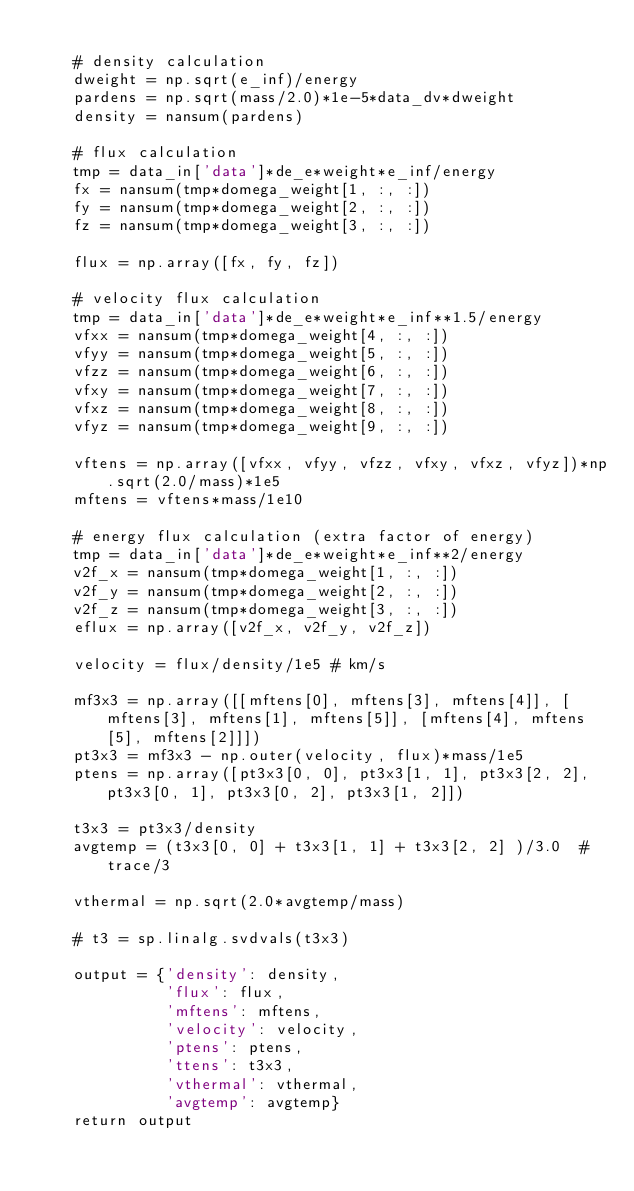<code> <loc_0><loc_0><loc_500><loc_500><_Python_>
    # density calculation
    dweight = np.sqrt(e_inf)/energy
    pardens = np.sqrt(mass/2.0)*1e-5*data_dv*dweight
    density = nansum(pardens)

    # flux calculation
    tmp = data_in['data']*de_e*weight*e_inf/energy
    fx = nansum(tmp*domega_weight[1, :, :])
    fy = nansum(tmp*domega_weight[2, :, :])
    fz = nansum(tmp*domega_weight[3, :, :])

    flux = np.array([fx, fy, fz])

    # velocity flux calculation
    tmp = data_in['data']*de_e*weight*e_inf**1.5/energy
    vfxx = nansum(tmp*domega_weight[4, :, :])
    vfyy = nansum(tmp*domega_weight[5, :, :])
    vfzz = nansum(tmp*domega_weight[6, :, :])
    vfxy = nansum(tmp*domega_weight[7, :, :])
    vfxz = nansum(tmp*domega_weight[8, :, :])
    vfyz = nansum(tmp*domega_weight[9, :, :])

    vftens = np.array([vfxx, vfyy, vfzz, vfxy, vfxz, vfyz])*np.sqrt(2.0/mass)*1e5
    mftens = vftens*mass/1e10

    # energy flux calculation (extra factor of energy)
    tmp = data_in['data']*de_e*weight*e_inf**2/energy
    v2f_x = nansum(tmp*domega_weight[1, :, :])
    v2f_y = nansum(tmp*domega_weight[2, :, :])
    v2f_z = nansum(tmp*domega_weight[3, :, :])
    eflux = np.array([v2f_x, v2f_y, v2f_z])

    velocity = flux/density/1e5 # km/s

    mf3x3 = np.array([[mftens[0], mftens[3], mftens[4]], [mftens[3], mftens[1], mftens[5]], [mftens[4], mftens[5], mftens[2]]])
    pt3x3 = mf3x3 - np.outer(velocity, flux)*mass/1e5
    ptens = np.array([pt3x3[0, 0], pt3x3[1, 1], pt3x3[2, 2], pt3x3[0, 1], pt3x3[0, 2], pt3x3[1, 2]])

    t3x3 = pt3x3/density
    avgtemp = (t3x3[0, 0] + t3x3[1, 1] + t3x3[2, 2] )/3.0  # trace/3

    vthermal = np.sqrt(2.0*avgtemp/mass)

    # t3 = sp.linalg.svdvals(t3x3)
    
    output = {'density': density, 
              'flux': flux, 
              'mftens': mftens, 
              'velocity': velocity, 
              'ptens': ptens, 
              'ttens': t3x3, 
              'vthermal': vthermal,
              'avgtemp': avgtemp}
    return output</code> 